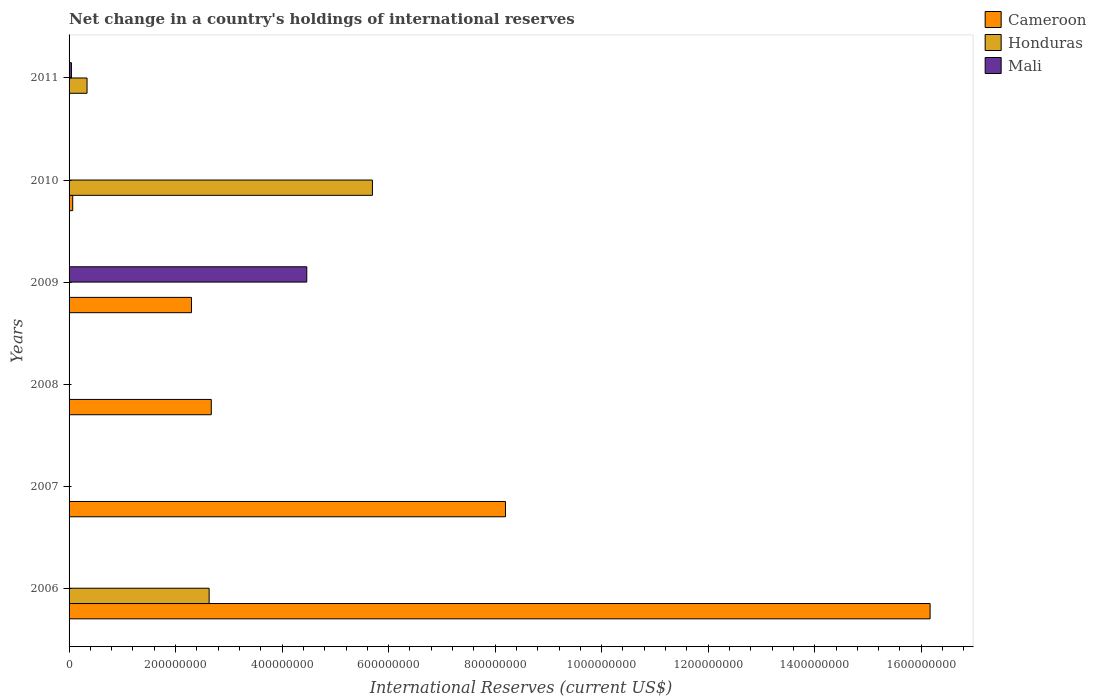How many different coloured bars are there?
Offer a very short reply. 3. Are the number of bars per tick equal to the number of legend labels?
Make the answer very short. No. Are the number of bars on each tick of the Y-axis equal?
Your answer should be very brief. No. How many bars are there on the 2nd tick from the bottom?
Provide a succinct answer. 1. In how many cases, is the number of bars for a given year not equal to the number of legend labels?
Offer a very short reply. 6. Across all years, what is the maximum international reserves in Cameroon?
Ensure brevity in your answer.  1.62e+09. In which year was the international reserves in Cameroon maximum?
Provide a succinct answer. 2006. What is the total international reserves in Honduras in the graph?
Ensure brevity in your answer.  8.66e+08. What is the difference between the international reserves in Honduras in 2010 and that in 2011?
Your answer should be compact. 5.36e+08. What is the difference between the international reserves in Mali in 2010 and the international reserves in Cameroon in 2006?
Keep it short and to the point. -1.62e+09. What is the average international reserves in Cameroon per year?
Your response must be concise. 4.90e+08. In the year 2010, what is the difference between the international reserves in Cameroon and international reserves in Honduras?
Keep it short and to the point. -5.63e+08. In how many years, is the international reserves in Mali greater than 1600000000 US$?
Provide a succinct answer. 0. What is the ratio of the international reserves in Cameroon in 2007 to that in 2009?
Keep it short and to the point. 3.57. Is the international reserves in Cameroon in 2006 less than that in 2007?
Keep it short and to the point. No. What is the difference between the highest and the second highest international reserves in Honduras?
Provide a succinct answer. 3.07e+08. What is the difference between the highest and the lowest international reserves in Mali?
Ensure brevity in your answer.  4.46e+08. Is the sum of the international reserves in Cameroon in 2008 and 2009 greater than the maximum international reserves in Honduras across all years?
Your answer should be very brief. No. Is it the case that in every year, the sum of the international reserves in Mali and international reserves in Cameroon is greater than the international reserves in Honduras?
Offer a terse response. No. Are all the bars in the graph horizontal?
Offer a terse response. Yes. How many years are there in the graph?
Give a very brief answer. 6. What is the difference between two consecutive major ticks on the X-axis?
Ensure brevity in your answer.  2.00e+08. Are the values on the major ticks of X-axis written in scientific E-notation?
Make the answer very short. No. Does the graph contain any zero values?
Offer a very short reply. Yes. Does the graph contain grids?
Your answer should be compact. No. Where does the legend appear in the graph?
Offer a very short reply. Top right. How many legend labels are there?
Ensure brevity in your answer.  3. What is the title of the graph?
Offer a terse response. Net change in a country's holdings of international reserves. What is the label or title of the X-axis?
Your answer should be very brief. International Reserves (current US$). What is the International Reserves (current US$) in Cameroon in 2006?
Make the answer very short. 1.62e+09. What is the International Reserves (current US$) in Honduras in 2006?
Make the answer very short. 2.63e+08. What is the International Reserves (current US$) of Cameroon in 2007?
Your response must be concise. 8.19e+08. What is the International Reserves (current US$) in Cameroon in 2008?
Offer a terse response. 2.67e+08. What is the International Reserves (current US$) in Honduras in 2008?
Provide a succinct answer. 0. What is the International Reserves (current US$) of Cameroon in 2009?
Provide a short and direct response. 2.30e+08. What is the International Reserves (current US$) of Mali in 2009?
Ensure brevity in your answer.  4.46e+08. What is the International Reserves (current US$) of Cameroon in 2010?
Your answer should be compact. 6.84e+06. What is the International Reserves (current US$) of Honduras in 2010?
Provide a succinct answer. 5.70e+08. What is the International Reserves (current US$) in Honduras in 2011?
Make the answer very short. 3.38e+07. What is the International Reserves (current US$) of Mali in 2011?
Provide a succinct answer. 4.43e+06. Across all years, what is the maximum International Reserves (current US$) of Cameroon?
Provide a short and direct response. 1.62e+09. Across all years, what is the maximum International Reserves (current US$) of Honduras?
Offer a very short reply. 5.70e+08. Across all years, what is the maximum International Reserves (current US$) in Mali?
Your response must be concise. 4.46e+08. Across all years, what is the minimum International Reserves (current US$) in Cameroon?
Ensure brevity in your answer.  0. Across all years, what is the minimum International Reserves (current US$) of Mali?
Your response must be concise. 0. What is the total International Reserves (current US$) in Cameroon in the graph?
Give a very brief answer. 2.94e+09. What is the total International Reserves (current US$) in Honduras in the graph?
Offer a terse response. 8.66e+08. What is the total International Reserves (current US$) in Mali in the graph?
Your answer should be compact. 4.51e+08. What is the difference between the International Reserves (current US$) in Cameroon in 2006 and that in 2007?
Your answer should be very brief. 7.97e+08. What is the difference between the International Reserves (current US$) in Cameroon in 2006 and that in 2008?
Your answer should be compact. 1.35e+09. What is the difference between the International Reserves (current US$) of Cameroon in 2006 and that in 2009?
Your answer should be very brief. 1.39e+09. What is the difference between the International Reserves (current US$) in Cameroon in 2006 and that in 2010?
Keep it short and to the point. 1.61e+09. What is the difference between the International Reserves (current US$) of Honduras in 2006 and that in 2010?
Give a very brief answer. -3.07e+08. What is the difference between the International Reserves (current US$) of Honduras in 2006 and that in 2011?
Your response must be concise. 2.29e+08. What is the difference between the International Reserves (current US$) of Cameroon in 2007 and that in 2008?
Offer a terse response. 5.52e+08. What is the difference between the International Reserves (current US$) in Cameroon in 2007 and that in 2009?
Your answer should be very brief. 5.90e+08. What is the difference between the International Reserves (current US$) of Cameroon in 2007 and that in 2010?
Keep it short and to the point. 8.13e+08. What is the difference between the International Reserves (current US$) of Cameroon in 2008 and that in 2009?
Offer a terse response. 3.72e+07. What is the difference between the International Reserves (current US$) in Cameroon in 2008 and that in 2010?
Make the answer very short. 2.60e+08. What is the difference between the International Reserves (current US$) of Cameroon in 2009 and that in 2010?
Ensure brevity in your answer.  2.23e+08. What is the difference between the International Reserves (current US$) of Mali in 2009 and that in 2011?
Offer a terse response. 4.42e+08. What is the difference between the International Reserves (current US$) in Honduras in 2010 and that in 2011?
Provide a short and direct response. 5.36e+08. What is the difference between the International Reserves (current US$) in Cameroon in 2006 and the International Reserves (current US$) in Mali in 2009?
Offer a terse response. 1.17e+09. What is the difference between the International Reserves (current US$) of Honduras in 2006 and the International Reserves (current US$) of Mali in 2009?
Offer a terse response. -1.83e+08. What is the difference between the International Reserves (current US$) in Cameroon in 2006 and the International Reserves (current US$) in Honduras in 2010?
Offer a very short reply. 1.05e+09. What is the difference between the International Reserves (current US$) in Cameroon in 2006 and the International Reserves (current US$) in Honduras in 2011?
Your answer should be compact. 1.58e+09. What is the difference between the International Reserves (current US$) in Cameroon in 2006 and the International Reserves (current US$) in Mali in 2011?
Your answer should be compact. 1.61e+09. What is the difference between the International Reserves (current US$) in Honduras in 2006 and the International Reserves (current US$) in Mali in 2011?
Give a very brief answer. 2.59e+08. What is the difference between the International Reserves (current US$) in Cameroon in 2007 and the International Reserves (current US$) in Mali in 2009?
Ensure brevity in your answer.  3.73e+08. What is the difference between the International Reserves (current US$) of Cameroon in 2007 and the International Reserves (current US$) of Honduras in 2010?
Ensure brevity in your answer.  2.50e+08. What is the difference between the International Reserves (current US$) in Cameroon in 2007 and the International Reserves (current US$) in Honduras in 2011?
Your answer should be compact. 7.86e+08. What is the difference between the International Reserves (current US$) of Cameroon in 2007 and the International Reserves (current US$) of Mali in 2011?
Your response must be concise. 8.15e+08. What is the difference between the International Reserves (current US$) in Cameroon in 2008 and the International Reserves (current US$) in Mali in 2009?
Ensure brevity in your answer.  -1.79e+08. What is the difference between the International Reserves (current US$) of Cameroon in 2008 and the International Reserves (current US$) of Honduras in 2010?
Keep it short and to the point. -3.03e+08. What is the difference between the International Reserves (current US$) in Cameroon in 2008 and the International Reserves (current US$) in Honduras in 2011?
Provide a short and direct response. 2.33e+08. What is the difference between the International Reserves (current US$) in Cameroon in 2008 and the International Reserves (current US$) in Mali in 2011?
Ensure brevity in your answer.  2.63e+08. What is the difference between the International Reserves (current US$) of Cameroon in 2009 and the International Reserves (current US$) of Honduras in 2010?
Offer a terse response. -3.40e+08. What is the difference between the International Reserves (current US$) of Cameroon in 2009 and the International Reserves (current US$) of Honduras in 2011?
Offer a terse response. 1.96e+08. What is the difference between the International Reserves (current US$) in Cameroon in 2009 and the International Reserves (current US$) in Mali in 2011?
Your answer should be very brief. 2.25e+08. What is the difference between the International Reserves (current US$) in Cameroon in 2010 and the International Reserves (current US$) in Honduras in 2011?
Offer a terse response. -2.69e+07. What is the difference between the International Reserves (current US$) in Cameroon in 2010 and the International Reserves (current US$) in Mali in 2011?
Give a very brief answer. 2.41e+06. What is the difference between the International Reserves (current US$) in Honduras in 2010 and the International Reserves (current US$) in Mali in 2011?
Ensure brevity in your answer.  5.65e+08. What is the average International Reserves (current US$) of Cameroon per year?
Offer a terse response. 4.90e+08. What is the average International Reserves (current US$) of Honduras per year?
Offer a very short reply. 1.44e+08. What is the average International Reserves (current US$) of Mali per year?
Make the answer very short. 7.51e+07. In the year 2006, what is the difference between the International Reserves (current US$) of Cameroon and International Reserves (current US$) of Honduras?
Your answer should be compact. 1.35e+09. In the year 2009, what is the difference between the International Reserves (current US$) in Cameroon and International Reserves (current US$) in Mali?
Ensure brevity in your answer.  -2.17e+08. In the year 2010, what is the difference between the International Reserves (current US$) of Cameroon and International Reserves (current US$) of Honduras?
Ensure brevity in your answer.  -5.63e+08. In the year 2011, what is the difference between the International Reserves (current US$) of Honduras and International Reserves (current US$) of Mali?
Your answer should be very brief. 2.93e+07. What is the ratio of the International Reserves (current US$) in Cameroon in 2006 to that in 2007?
Ensure brevity in your answer.  1.97. What is the ratio of the International Reserves (current US$) in Cameroon in 2006 to that in 2008?
Offer a terse response. 6.05. What is the ratio of the International Reserves (current US$) of Cameroon in 2006 to that in 2009?
Provide a short and direct response. 7.04. What is the ratio of the International Reserves (current US$) in Cameroon in 2006 to that in 2010?
Make the answer very short. 236.17. What is the ratio of the International Reserves (current US$) of Honduras in 2006 to that in 2010?
Offer a very short reply. 0.46. What is the ratio of the International Reserves (current US$) in Honduras in 2006 to that in 2011?
Keep it short and to the point. 7.79. What is the ratio of the International Reserves (current US$) of Cameroon in 2007 to that in 2008?
Ensure brevity in your answer.  3.07. What is the ratio of the International Reserves (current US$) of Cameroon in 2007 to that in 2009?
Ensure brevity in your answer.  3.57. What is the ratio of the International Reserves (current US$) of Cameroon in 2007 to that in 2010?
Your answer should be compact. 119.7. What is the ratio of the International Reserves (current US$) in Cameroon in 2008 to that in 2009?
Provide a succinct answer. 1.16. What is the ratio of the International Reserves (current US$) in Cameroon in 2008 to that in 2010?
Offer a very short reply. 39.01. What is the ratio of the International Reserves (current US$) of Cameroon in 2009 to that in 2010?
Your answer should be very brief. 33.57. What is the ratio of the International Reserves (current US$) of Mali in 2009 to that in 2011?
Your response must be concise. 100.72. What is the ratio of the International Reserves (current US$) of Honduras in 2010 to that in 2011?
Keep it short and to the point. 16.87. What is the difference between the highest and the second highest International Reserves (current US$) of Cameroon?
Make the answer very short. 7.97e+08. What is the difference between the highest and the second highest International Reserves (current US$) of Honduras?
Provide a succinct answer. 3.07e+08. What is the difference between the highest and the lowest International Reserves (current US$) in Cameroon?
Your answer should be compact. 1.62e+09. What is the difference between the highest and the lowest International Reserves (current US$) in Honduras?
Your answer should be compact. 5.70e+08. What is the difference between the highest and the lowest International Reserves (current US$) in Mali?
Provide a succinct answer. 4.46e+08. 